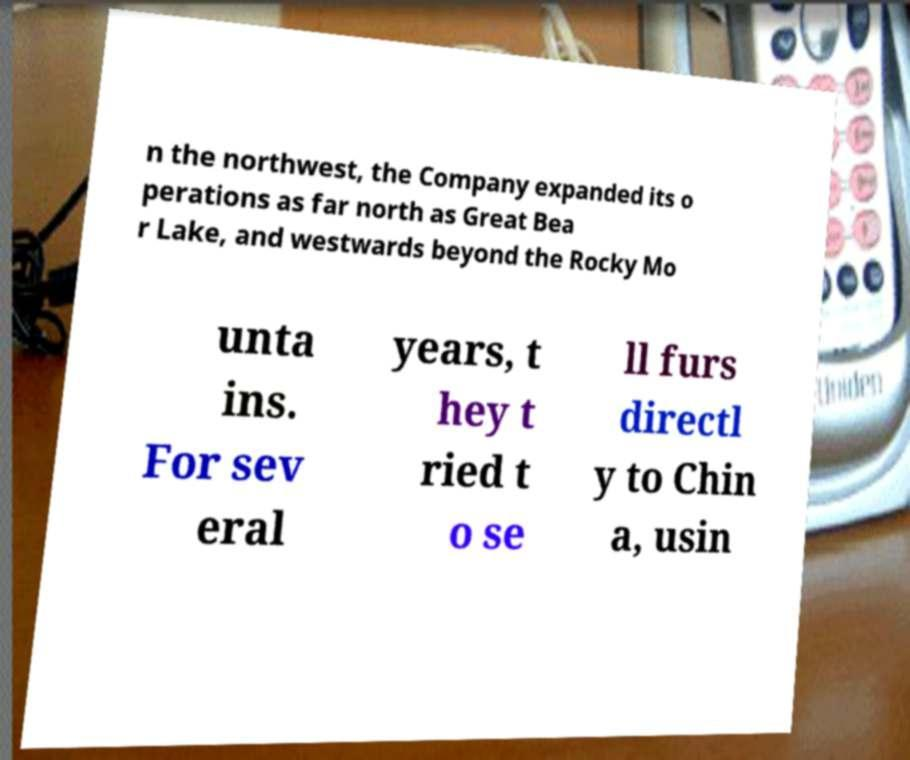Could you extract and type out the text from this image? n the northwest, the Company expanded its o perations as far north as Great Bea r Lake, and westwards beyond the Rocky Mo unta ins. For sev eral years, t hey t ried t o se ll furs directl y to Chin a, usin 